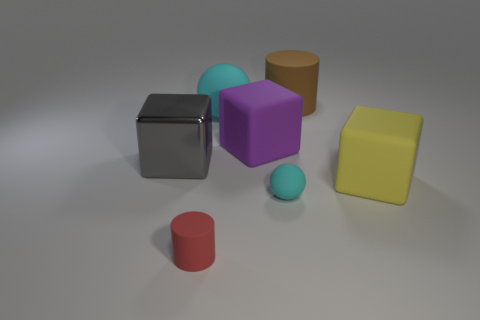Subtract all big matte blocks. How many blocks are left? 1 Add 1 large gray things. How many objects exist? 8 Subtract all cubes. How many objects are left? 4 Subtract all red cubes. How many green cylinders are left? 0 Subtract all gray cubes. How many cubes are left? 2 Subtract 1 blocks. How many blocks are left? 2 Subtract all green cubes. Subtract all blue cylinders. How many cubes are left? 3 Subtract all large gray cylinders. Subtract all metal blocks. How many objects are left? 6 Add 7 matte cylinders. How many matte cylinders are left? 9 Add 7 big cyan rubber balls. How many big cyan rubber balls exist? 8 